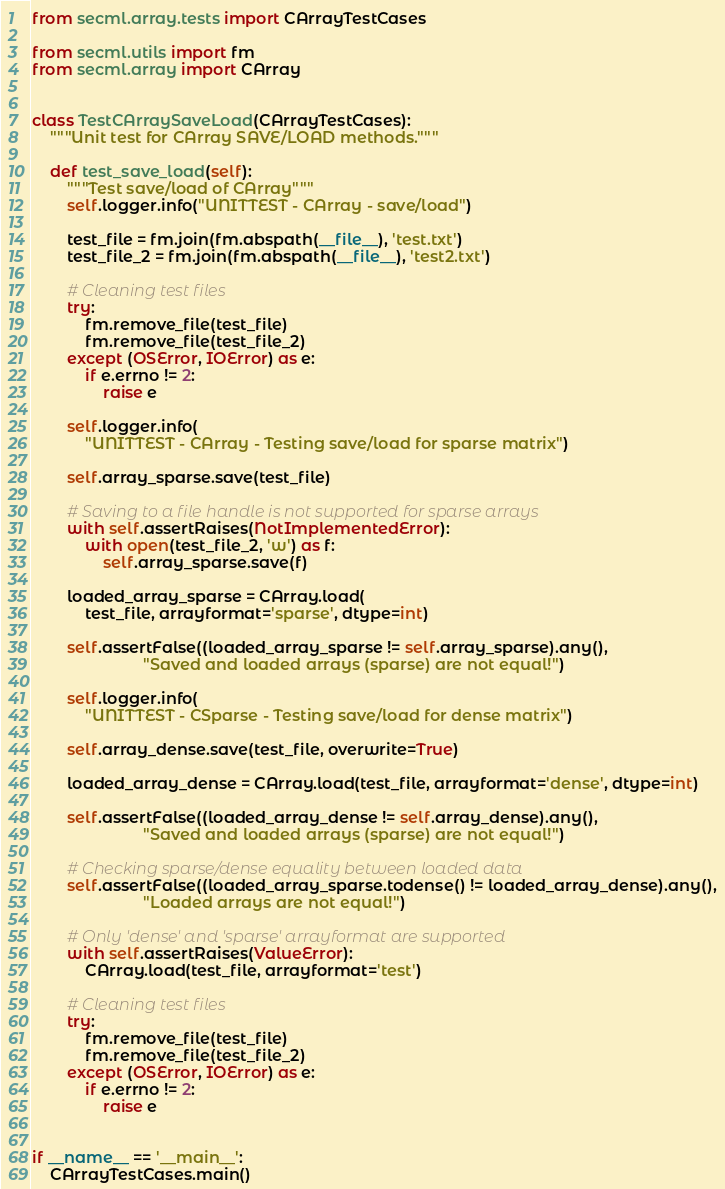Convert code to text. <code><loc_0><loc_0><loc_500><loc_500><_Python_>from secml.array.tests import CArrayTestCases

from secml.utils import fm
from secml.array import CArray


class TestCArraySaveLoad(CArrayTestCases):
    """Unit test for CArray SAVE/LOAD methods."""

    def test_save_load(self):
        """Test save/load of CArray"""
        self.logger.info("UNITTEST - CArray - save/load")

        test_file = fm.join(fm.abspath(__file__), 'test.txt')
        test_file_2 = fm.join(fm.abspath(__file__), 'test2.txt')

        # Cleaning test files
        try:
            fm.remove_file(test_file)
            fm.remove_file(test_file_2)
        except (OSError, IOError) as e:
            if e.errno != 2:
                raise e

        self.logger.info(
            "UNITTEST - CArray - Testing save/load for sparse matrix")

        self.array_sparse.save(test_file)

        # Saving to a file handle is not supported for sparse arrays
        with self.assertRaises(NotImplementedError):
            with open(test_file_2, 'w') as f:
                self.array_sparse.save(f)

        loaded_array_sparse = CArray.load(
            test_file, arrayformat='sparse', dtype=int)

        self.assertFalse((loaded_array_sparse != self.array_sparse).any(),
                         "Saved and loaded arrays (sparse) are not equal!")

        self.logger.info(
            "UNITTEST - CSparse - Testing save/load for dense matrix")

        self.array_dense.save(test_file, overwrite=True)

        loaded_array_dense = CArray.load(test_file, arrayformat='dense', dtype=int)

        self.assertFalse((loaded_array_dense != self.array_dense).any(),
                         "Saved and loaded arrays (sparse) are not equal!")

        # Checking sparse/dense equality between loaded data
        self.assertFalse((loaded_array_sparse.todense() != loaded_array_dense).any(),
                         "Loaded arrays are not equal!")

        # Only 'dense' and 'sparse' arrayformat are supported
        with self.assertRaises(ValueError):
            CArray.load(test_file, arrayformat='test')

        # Cleaning test files
        try:
            fm.remove_file(test_file)
            fm.remove_file(test_file_2)
        except (OSError, IOError) as e:
            if e.errno != 2:
                raise e


if __name__ == '__main__':
    CArrayTestCases.main()
</code> 